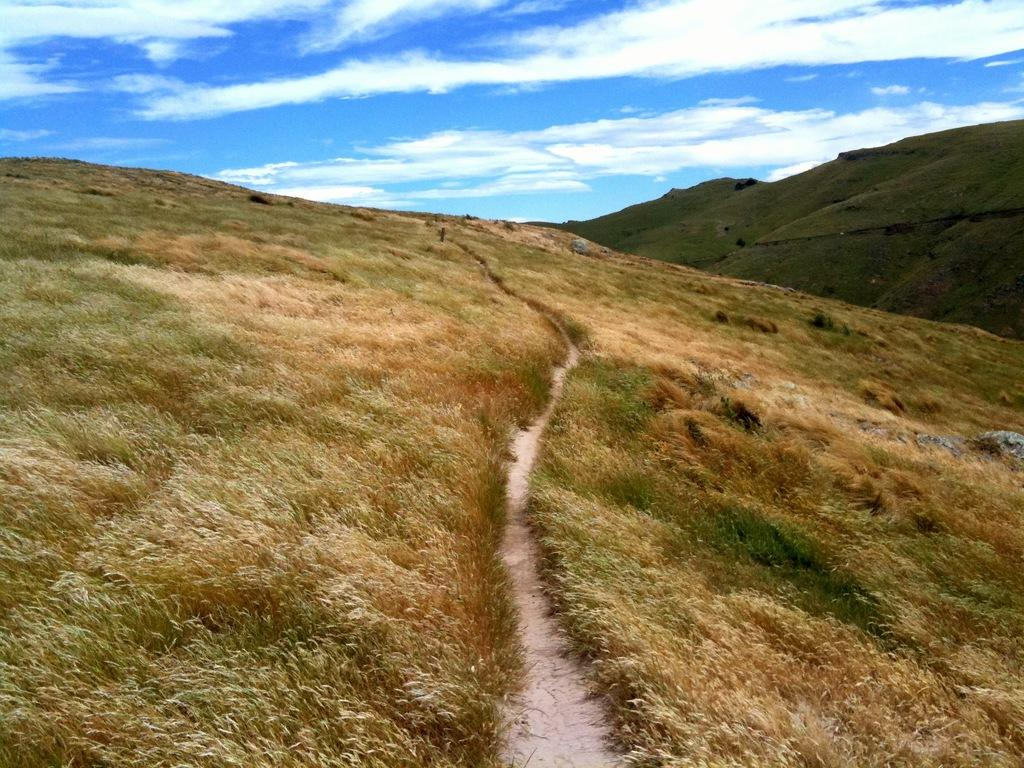What type of terrain is visible in the image? There is grass and sand visible in the image. What other objects can be seen in the image? There are stones in the image. What is located on the right side of the image? There are mountains on the right side of the image. What is visible in the sky in the image? There are clouds in the sky. What type of straw is being used to create order in the image? There is no straw or order being established in the image; it features natural elements like grass, sand, stones, mountains, and clouds. 